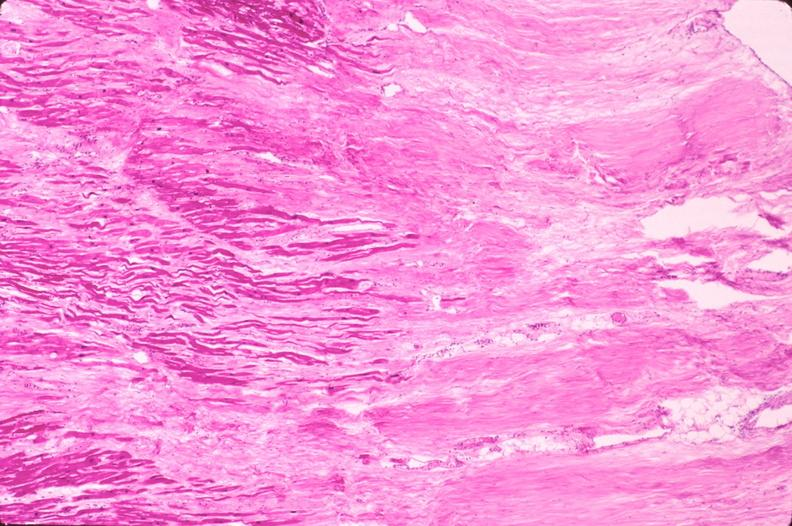where is this in?
Answer the question using a single word or phrase. In vasculature 